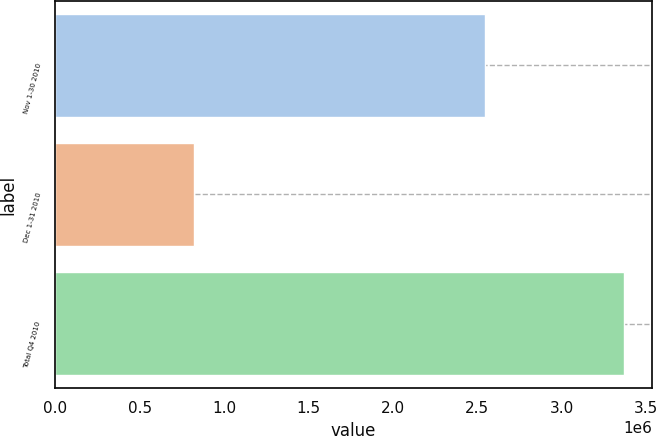Convert chart. <chart><loc_0><loc_0><loc_500><loc_500><bar_chart><fcel>Nov 1-30 2010<fcel>Dec 1-31 2010<fcel>Total Q4 2010<nl><fcel>2.54379e+06<fcel>822099<fcel>3.36589e+06<nl></chart> 